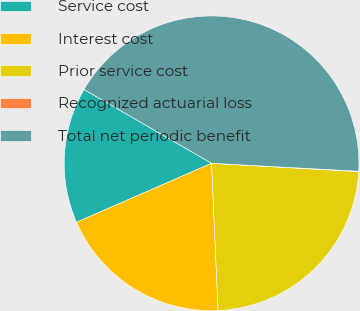Convert chart. <chart><loc_0><loc_0><loc_500><loc_500><pie_chart><fcel>Service cost<fcel>Interest cost<fcel>Prior service cost<fcel>Recognized actuarial loss<fcel>Total net periodic benefit<nl><fcel>14.9%<fcel>19.15%<fcel>23.4%<fcel>0.04%<fcel>42.51%<nl></chart> 